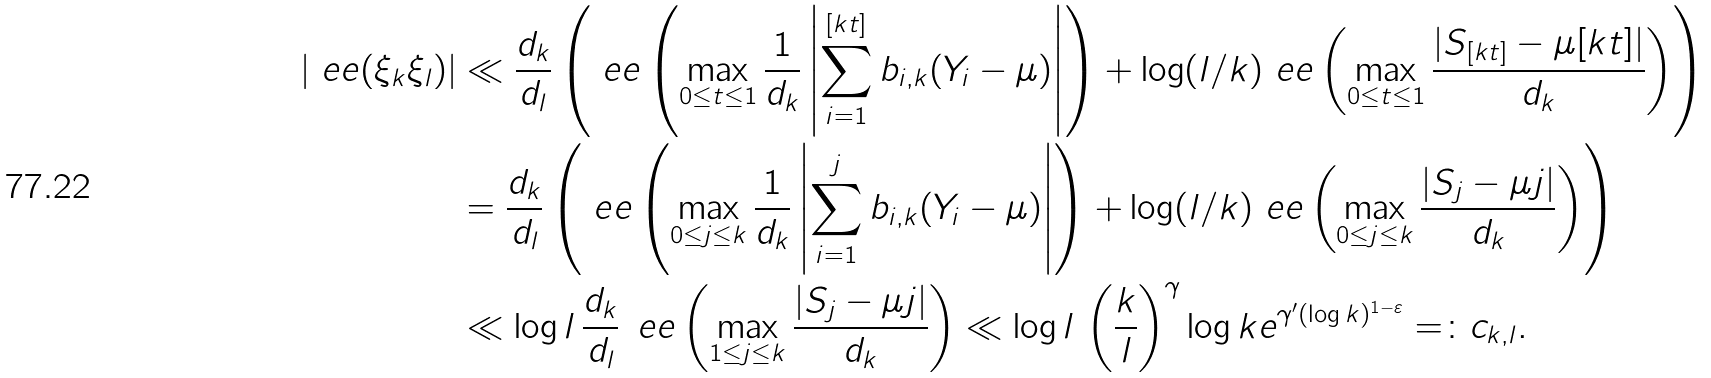<formula> <loc_0><loc_0><loc_500><loc_500>\left | \ e e ( \xi _ { k } \xi _ { l } ) \right | & \ll \frac { d _ { k } } { d _ { l } } \left ( \ e e \left ( \max _ { 0 \leq t \leq 1 } \frac { 1 } { d _ { k } } \left | \sum _ { i = 1 } ^ { [ k t ] } { b _ { i , k } } ( Y _ { i } - \mu ) \right | \right ) + \log ( l / k ) \ e e \left ( \max _ { 0 \leq t \leq 1 } \frac { | S _ { [ k t ] } - \mu [ k t ] | } { d _ { k } } \right ) \right ) \\ & = \frac { d _ { k } } { d _ { l } } \left ( \ e e \left ( \max _ { 0 \leq j \leq k } \frac { 1 } { d _ { k } } \left | \sum _ { i = 1 } ^ { j } { b _ { i , k } } ( Y _ { i } - \mu ) \right | \right ) + \log ( l / k ) \ e e \left ( \max _ { 0 \leq j \leq k } \frac { | S _ { j } - \mu j | } { d _ { k } } \right ) \right ) \\ & \ll \log l \, \frac { d _ { k } } { d _ { l } } \, \ e e \left ( \max _ { 1 \leq j \leq k } \frac { | S _ { j } - \mu j | } { d _ { k } } \right ) \ll \log l \, \left ( \frac { k } { l } \right ) ^ { \gamma } \log k e ^ { \gamma ^ { \prime } ( \log k ) ^ { 1 - \varepsilon } } = \colon c _ { k , l } .</formula> 